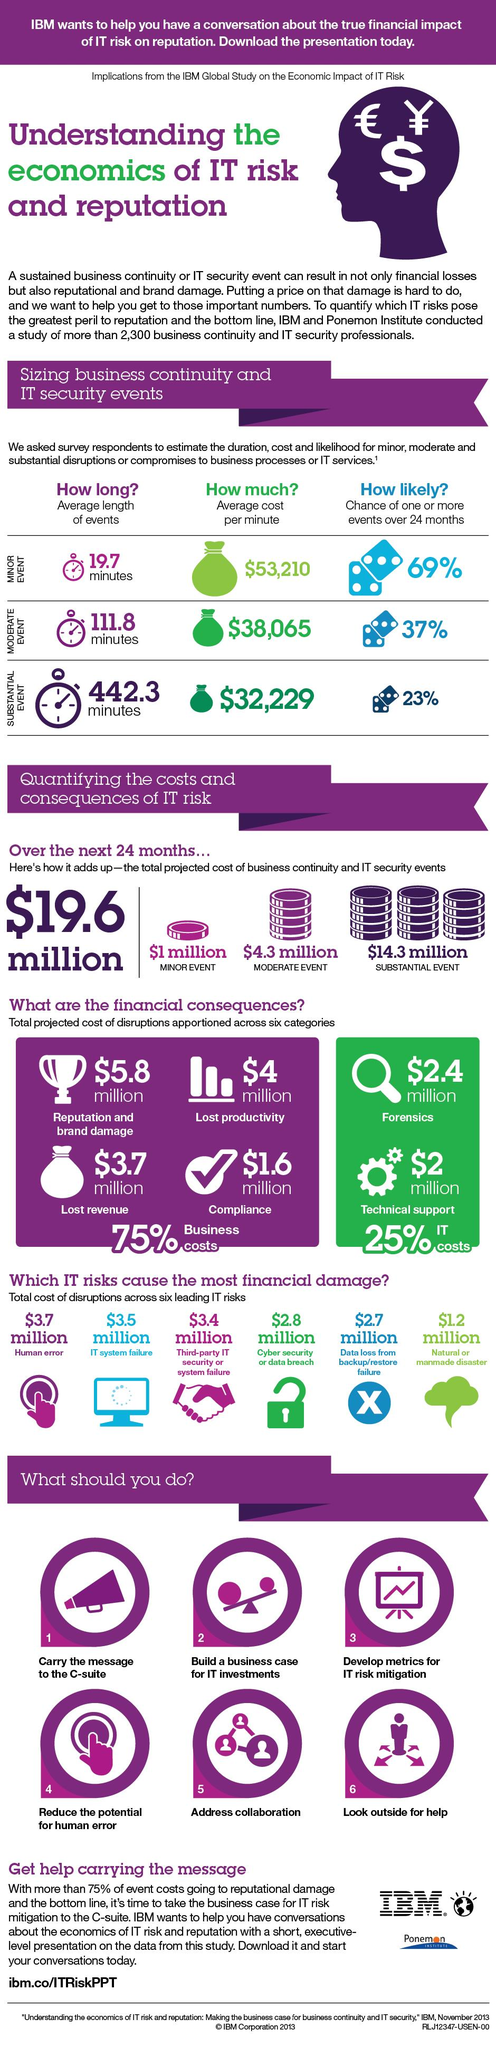Give some essential details in this illustration. The total cost of disruptions caused by cyber security or data breach is estimated to be approximately $2.8 million. There is a 37% probability that one or more moderate events will occur within the next 24 months. The average length of substantial events occurring over a period of 24 months is approximately 442.3 minutes. The total cost of disruptions caused by IT system failure is estimated to be $3.5 million. The total estimated cost of disruptions to the business is projected to be $3.7 million, which will be attributed to lost revenue. 